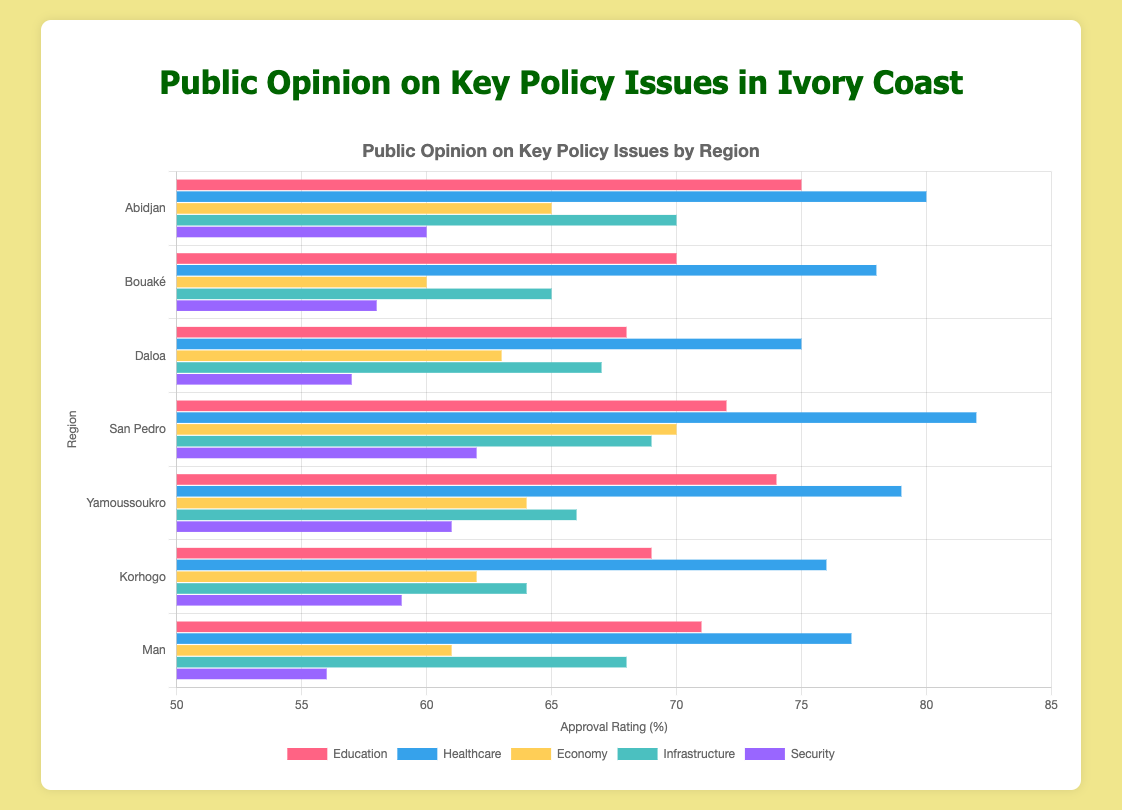What is the average approval rating for education across all regions? To find the average approval rating for education, add up the approval ratings from each region and divide by the number of regions: (75 + 70 + 68 + 72 + 74 + 69 + 71) / 7 = 499 / 7 = 71.29
Answer: 71.29 Which region has the highest approval rating for healthcare? To determine the region with the highest approval rating for healthcare, compare the healthcare ratings across all regions: Abidjan (80), Bouaké (78), Daloa (75), San Pedro (82), Yamoussoukro (79), Korhogo (76), Man (77). San Pedro has the highest rating of 82.
Answer: San Pedro Which policy issue has the lowest approval rating in the region of Man? Examine the approval ratings for all policy issues in Man: Education (71), Healthcare (77), Economy (61), Infrastructure (68), Security (56). The lowest rating is for Security at 56.
Answer: Security How much higher is the approval rating for infrastructure in Abidjan compared to Bouaké? Subtract the infrastructure approval rating of Bouaké from that of Abidjan: 70 (Abidjan) - 65 (Bouaké) = 5.
Answer: 5 What is the difference between the highest and lowest approval ratings for economy across all regions? Identify the highest and lowest approval ratings for economy: highest is 70 (San Pedro), lowest is 60 (Bouaké). The difference is 70 - 60 = 10.
Answer: 10 Which policy issue received the same approval rating in two different regions? Look for matching approval ratings: Education does not match, Healthcare does not match, Economy does not match, Infrastructure – check: Abidjan (70), Bouaké (65), Daloa (67), San Pedro (69), Yamoussoukro (66), Korhogo (64), Man (68). None match. Security – check: Abidjan (60), Bouaké (58), Daloa (57), San Pedro (62), Yamoussoukro (61), Korhogo (59), Man (56). None match. Thus, there is no policy issue with the same approval rating in two regions.
Answer: None Which region has the second highest approval rating for economy? Review the economy ratings across regions: Abidjan (65), Bouaké (60), Daloa (63), San Pedro (70), Yamoussoukro (64), Korhogo (62), Man (61). The highest is San Pedro (70), and the second highest is Abidjan (65).
Answer: Abidjan What is the combined approval rating for healthcare in Yamoussoukro and Korhogo? Add the healthcare approval ratings of Yamoussoukro and Korhogo: 79 (Yamoussoukro) + 76 (Korhogo) = 155.
Answer: 155 How does the approval rating for security in Bouaké compare to Korhogo? Compare the security ratings of Bouaké (58) and Korhogo (59). Bouaké's is 1 point lower than Korhogo's.
Answer: Lower by 1 